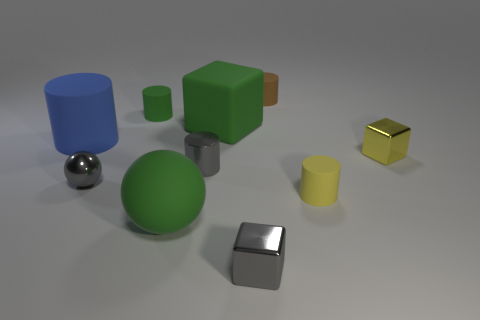There is a object that is on the left side of the green matte cylinder and to the right of the large matte cylinder; what is its material?
Keep it short and to the point. Metal. There is a matte thing that is both in front of the large rubber cylinder and to the right of the small gray block; what color is it?
Your answer should be very brief. Yellow. Is there anything else of the same color as the large block?
Offer a terse response. Yes. What is the shape of the large rubber object in front of the yellow object in front of the tiny metallic cube that is to the right of the small gray metal block?
Your response must be concise. Sphere. There is another metallic thing that is the same shape as the large blue object; what color is it?
Provide a succinct answer. Gray. The metal cube behind the small matte thing in front of the large blue rubber cylinder is what color?
Offer a terse response. Yellow. The yellow matte object that is the same shape as the blue matte object is what size?
Your answer should be very brief. Small. How many yellow cylinders have the same material as the brown cylinder?
Offer a terse response. 1. What number of metallic things are on the right side of the metallic block that is in front of the yellow shiny object?
Provide a short and direct response. 1. There is a green block; are there any big rubber things behind it?
Your response must be concise. No. 